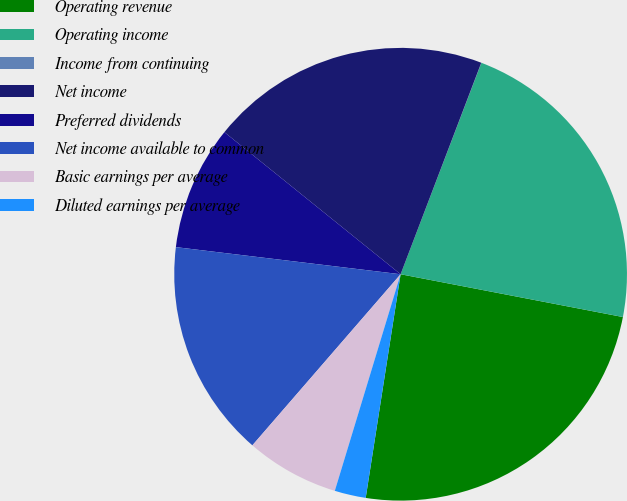Convert chart to OTSL. <chart><loc_0><loc_0><loc_500><loc_500><pie_chart><fcel>Operating revenue<fcel>Operating income<fcel>Income from continuing<fcel>Net income<fcel>Preferred dividends<fcel>Net income available to common<fcel>Basic earnings per average<fcel>Diluted earnings per average<nl><fcel>24.44%<fcel>22.22%<fcel>0.01%<fcel>20.0%<fcel>8.89%<fcel>15.55%<fcel>6.67%<fcel>2.23%<nl></chart> 